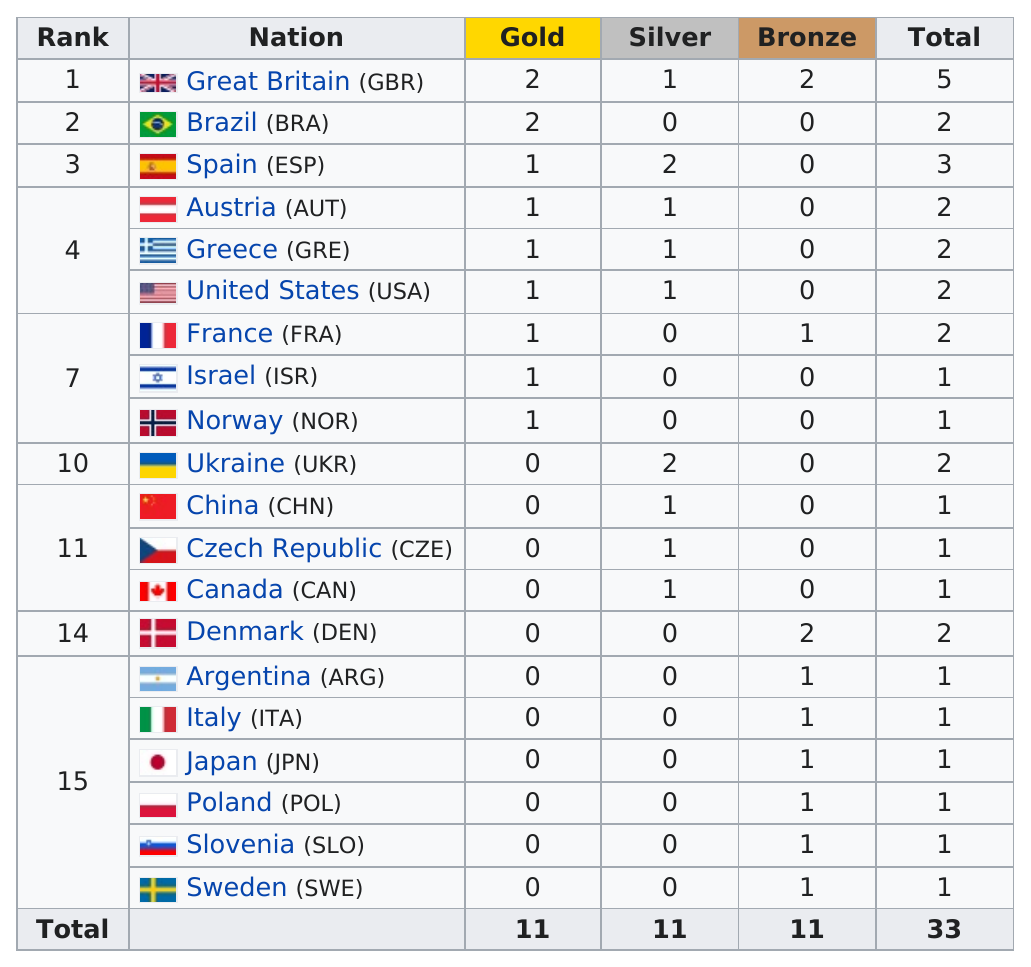Give some essential details in this illustration. Nine countries have won at least two medals in sailing. The United States won a total of 2 medals in the competition. Spain was the only nation to receive three medals. Spain was the nation that followed Great Britain in total medal count in the 2020 Summer Olympics. Nine countries won silver medals in sailing. 